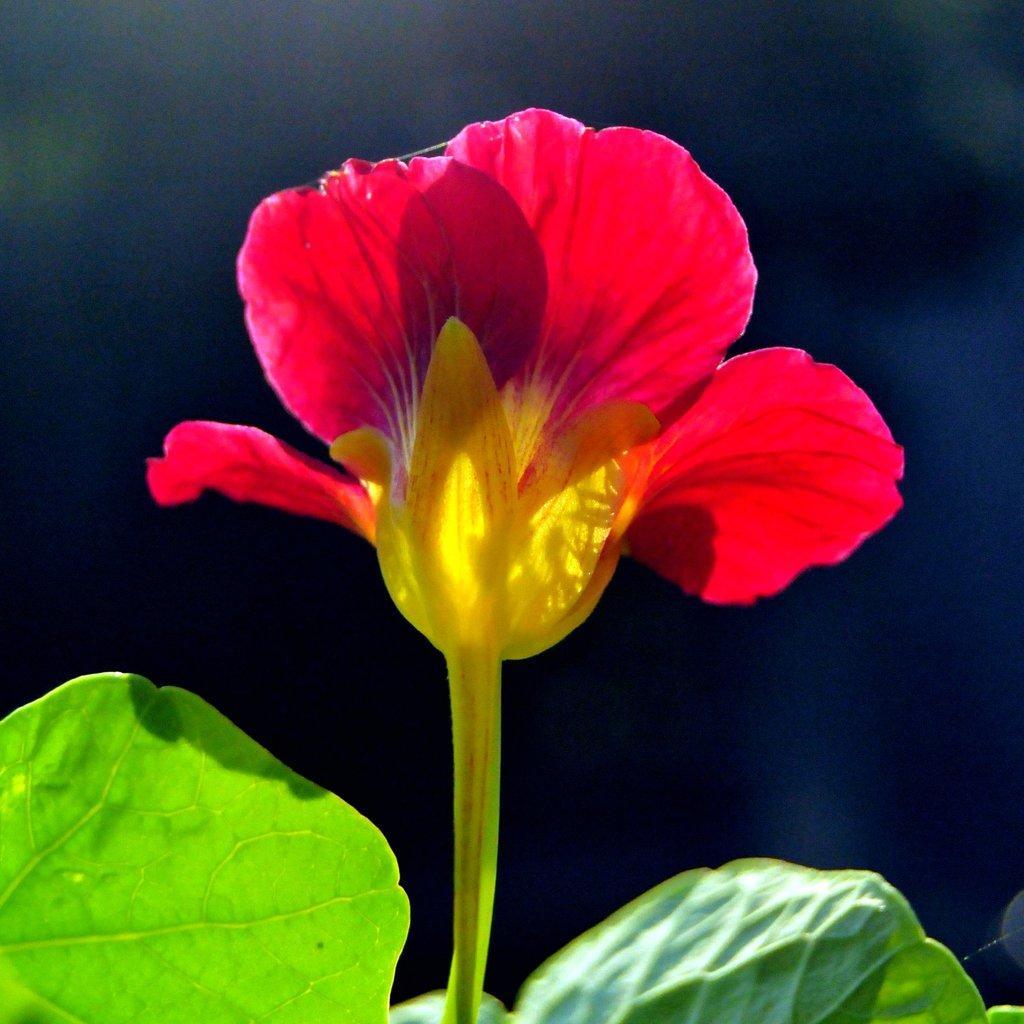Can you describe this image briefly? Here we can see a plant with a flower. In the background the image is blur. 